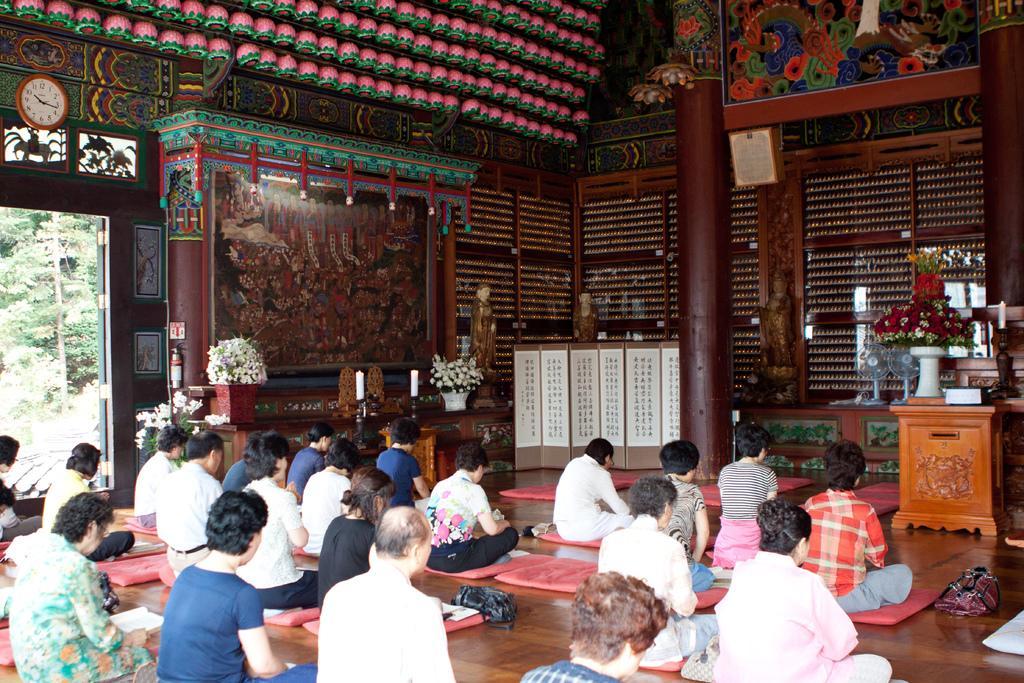Please provide a concise description of this image. This is the picture of a room where we have some people sitting on the floor mats and in front of them there is a table on which there is a flower vase and some other things and around there are some other things and a clock to the wall. 